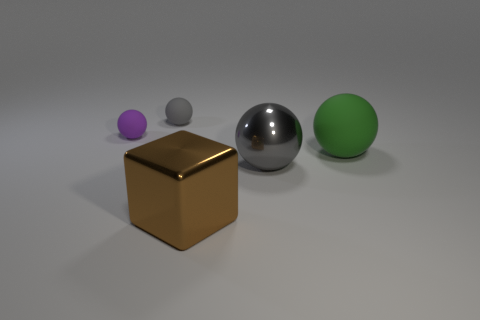Subtract 1 balls. How many balls are left? 3 Add 2 red cylinders. How many objects exist? 7 Subtract all balls. How many objects are left? 1 Add 1 metallic spheres. How many metallic spheres are left? 2 Add 4 large brown cubes. How many large brown cubes exist? 5 Subtract 0 green cylinders. How many objects are left? 5 Subtract all small gray things. Subtract all small gray rubber spheres. How many objects are left? 3 